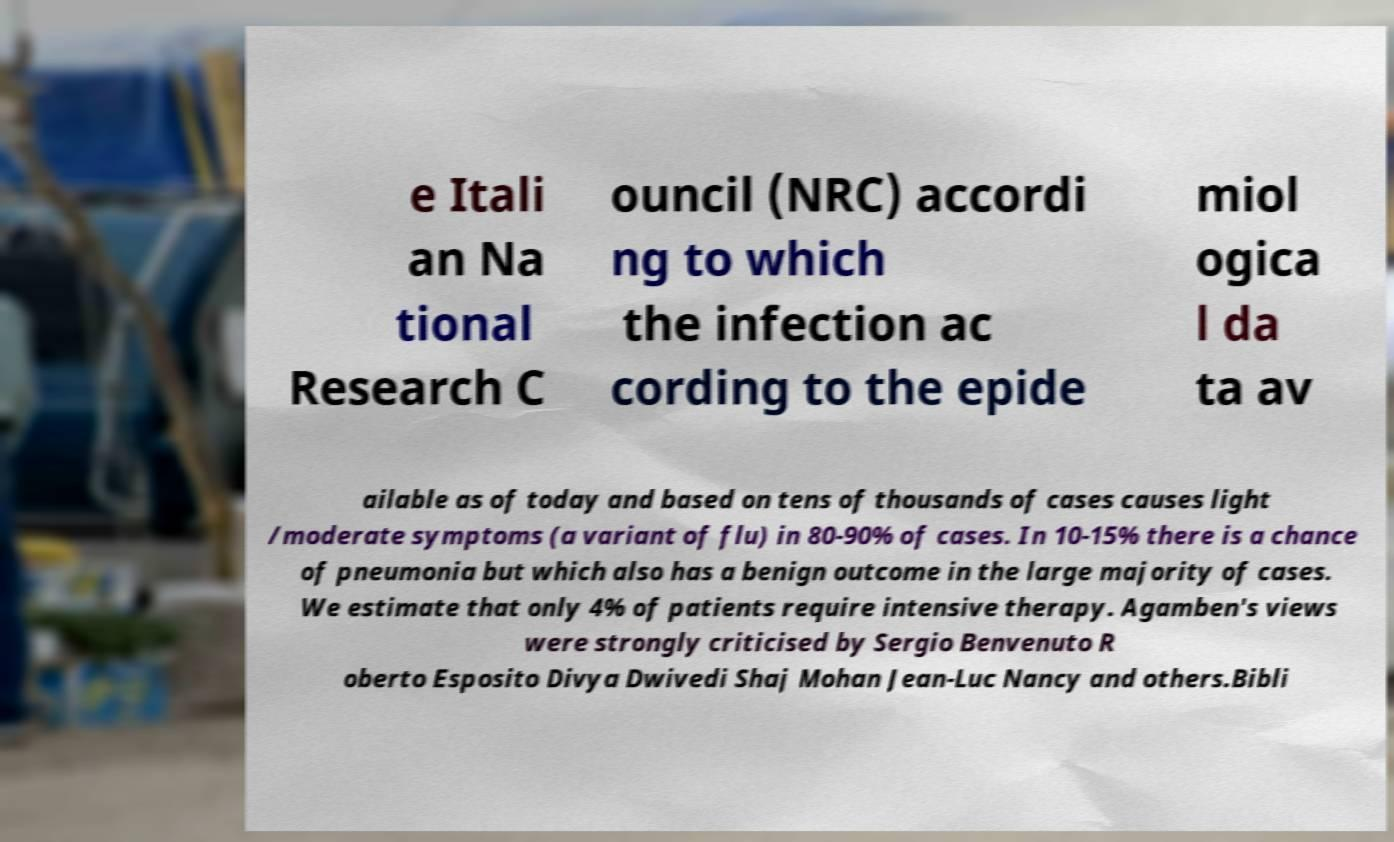For documentation purposes, I need the text within this image transcribed. Could you provide that? e Itali an Na tional Research C ouncil (NRC) accordi ng to which the infection ac cording to the epide miol ogica l da ta av ailable as of today and based on tens of thousands of cases causes light /moderate symptoms (a variant of flu) in 80-90% of cases. In 10-15% there is a chance of pneumonia but which also has a benign outcome in the large majority of cases. We estimate that only 4% of patients require intensive therapy. Agamben's views were strongly criticised by Sergio Benvenuto R oberto Esposito Divya Dwivedi Shaj Mohan Jean-Luc Nancy and others.Bibli 